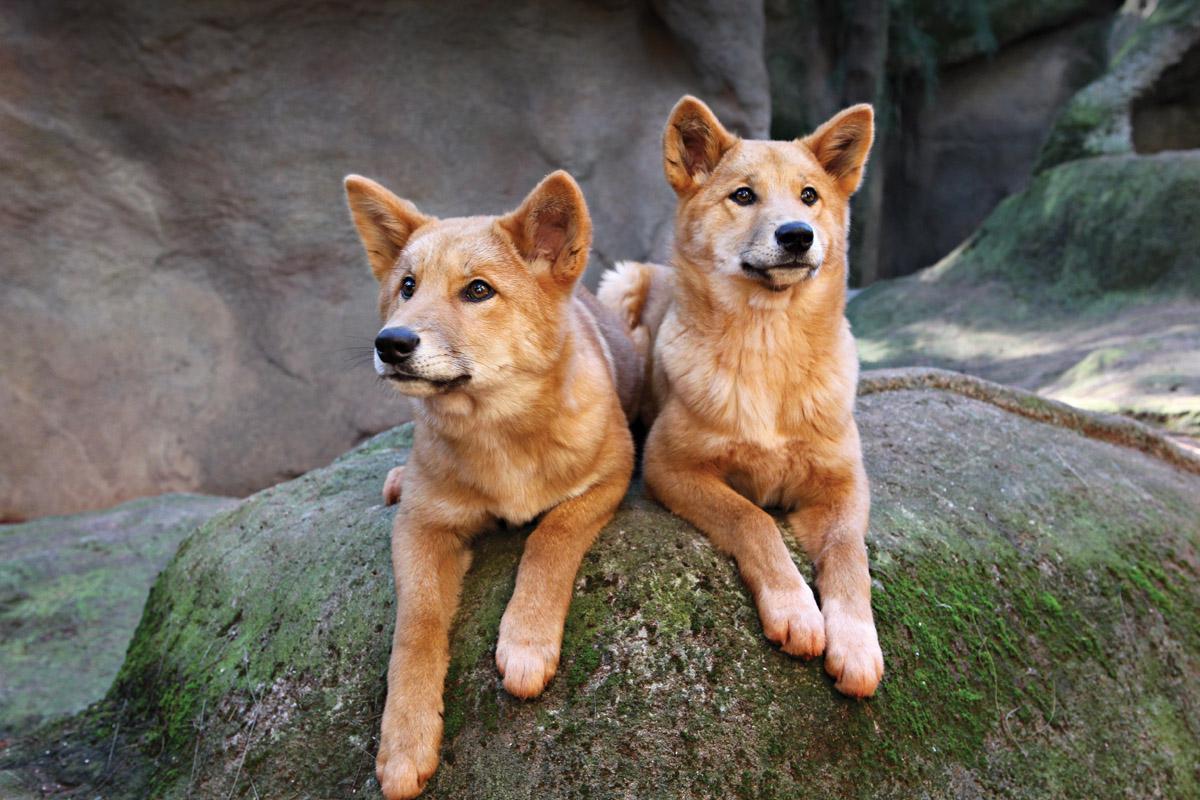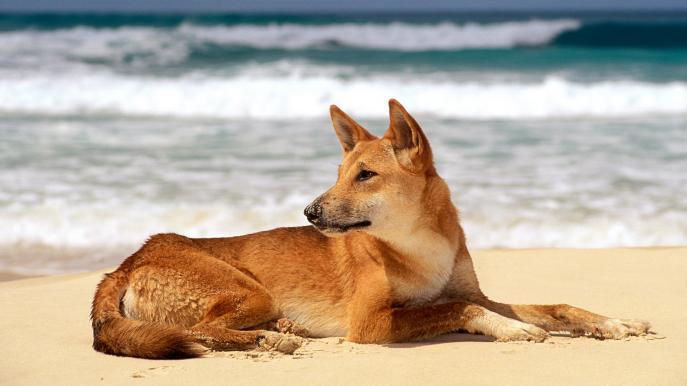The first image is the image on the left, the second image is the image on the right. Examine the images to the left and right. Is the description "In one image, the animal is standing over grass or other plant life." accurate? Answer yes or no. No. The first image is the image on the left, the second image is the image on the right. For the images displayed, is the sentence "There is at least one image there is a single yellow and white dog facing right with their heads turned left." factually correct? Answer yes or no. Yes. 